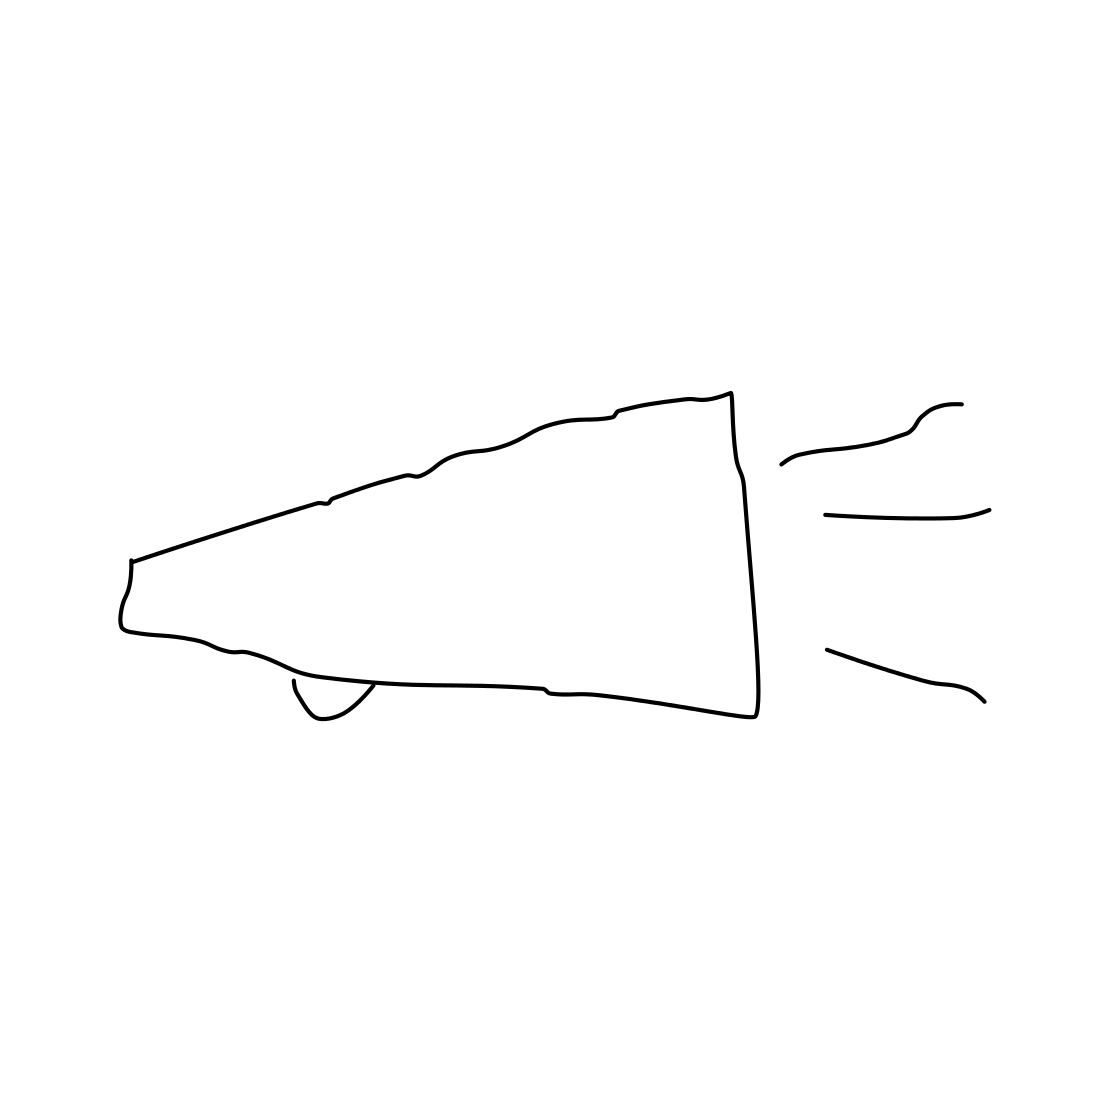What might be the significance of a megaphone in a protest context? In a protest context, a megaphone becomes a powerful symbol for voice and amplification of messages. It's used to project protesters' voices over the crowd, ensuring that their messages and chants are heard clearly. It often becomes a visual symbol representing the right to speak out and the power of collective voices in demanding change. 